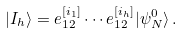Convert formula to latex. <formula><loc_0><loc_0><loc_500><loc_500>| I _ { h } \rangle = e _ { 1 2 } ^ { [ i _ { 1 } ] } \cdots e _ { 1 2 } ^ { [ i _ { h } ] } | \psi ^ { 0 } _ { N } \rangle \, .</formula> 